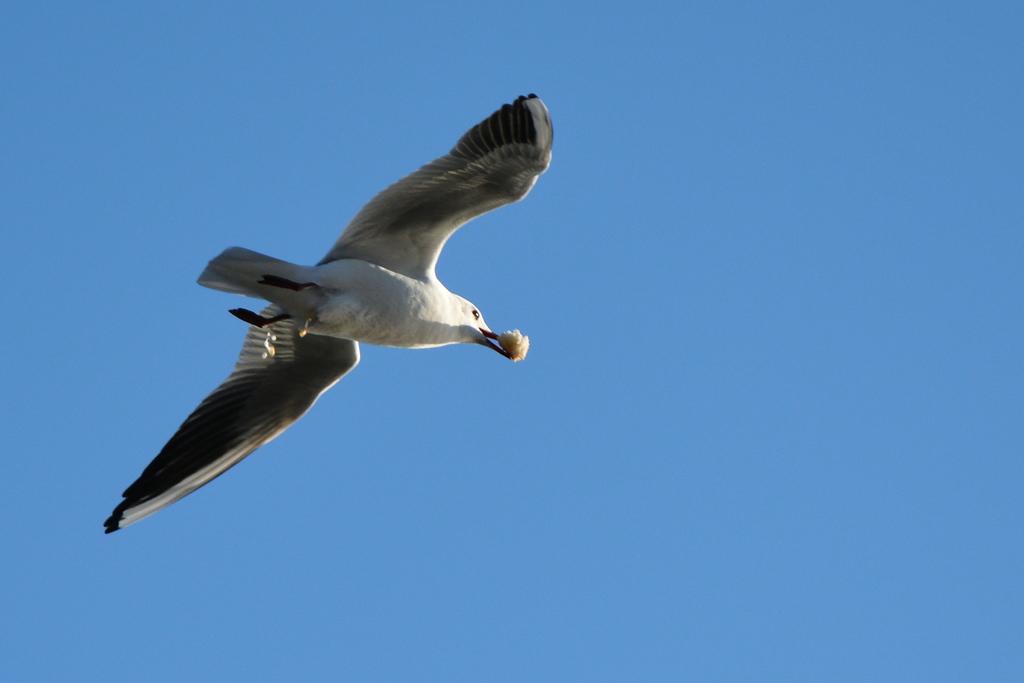Describe this image in one or two sentences. In this image, in the middle, we can see a bird which is flying in the air and also keeping some food item in its mouth. In the background, we can see a sky which is in blue color. 